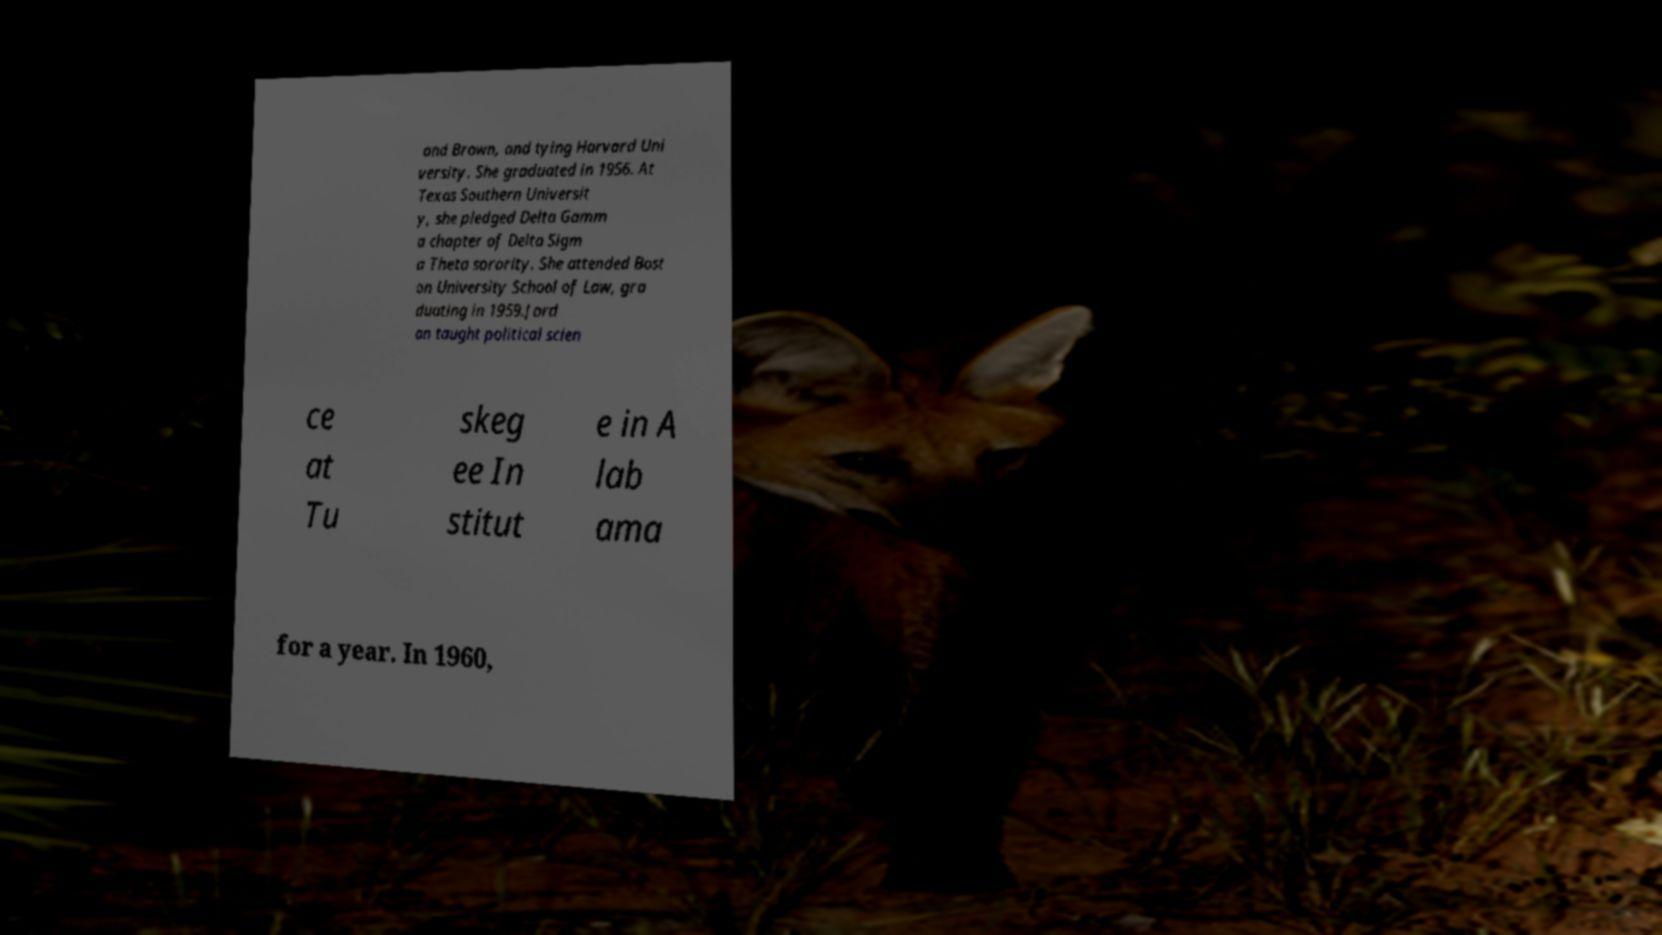For documentation purposes, I need the text within this image transcribed. Could you provide that? and Brown, and tying Harvard Uni versity. She graduated in 1956. At Texas Southern Universit y, she pledged Delta Gamm a chapter of Delta Sigm a Theta sorority. She attended Bost on University School of Law, gra duating in 1959.Jord an taught political scien ce at Tu skeg ee In stitut e in A lab ama for a year. In 1960, 